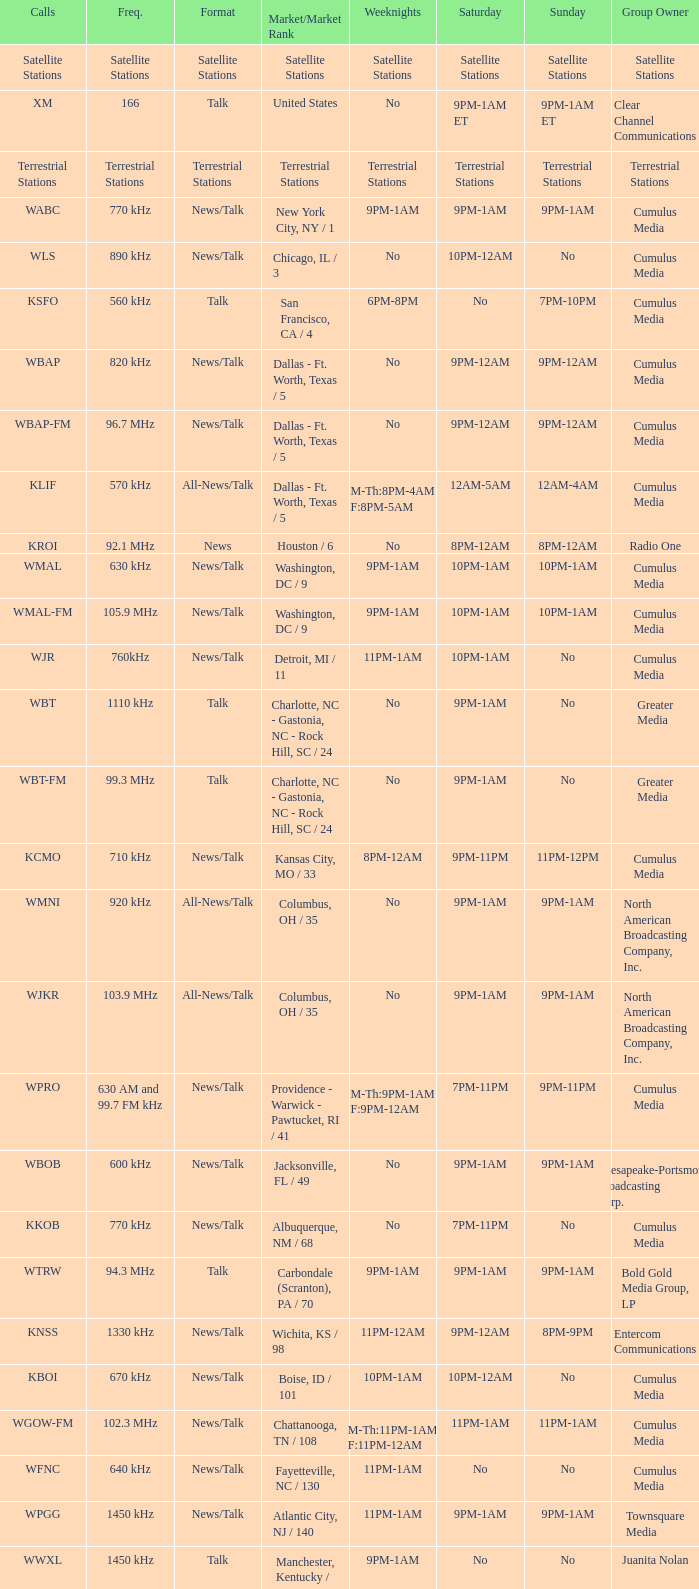What is the market for the 11pm-1am Saturday game? Chattanooga, TN / 108. 